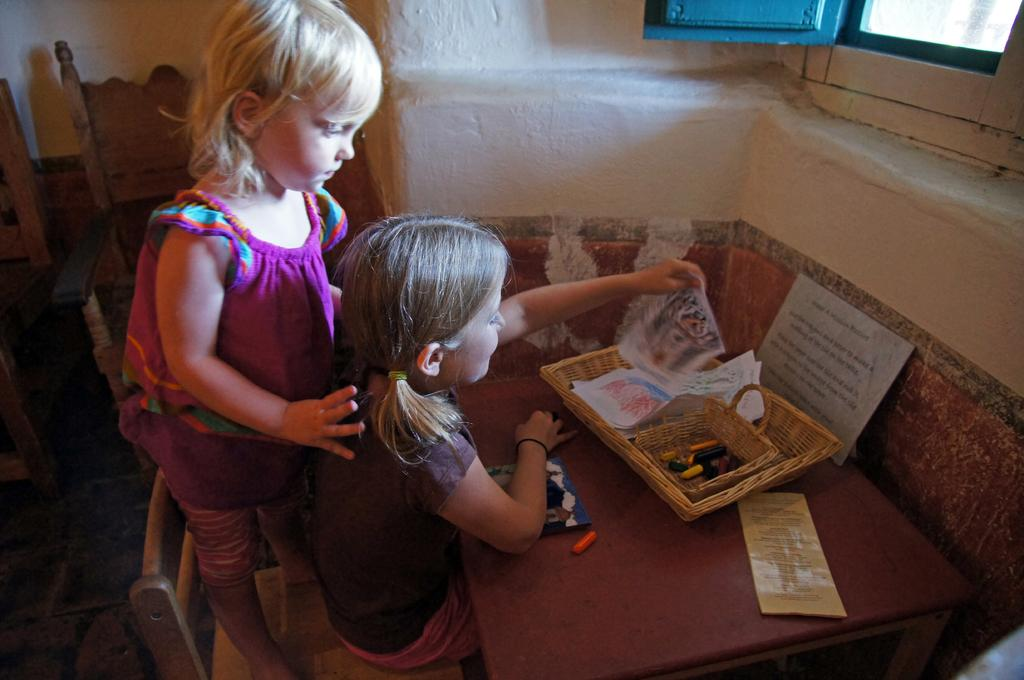How many baby girls are in the image? There are two baby girls in the image. What is the position of the first baby girl? One of the baby girls is sitting. What is the position of the second baby girl? The other baby girl is standing on a wooden chair. What is the condition of the border surrounding the image? There is no information provided about the border surrounding the image, so it cannot be determined. What type of vessel is being used by the baby girls in the image? There is no vessel present in the image; the baby girls are on a wooden chair and sitting on the floor. 